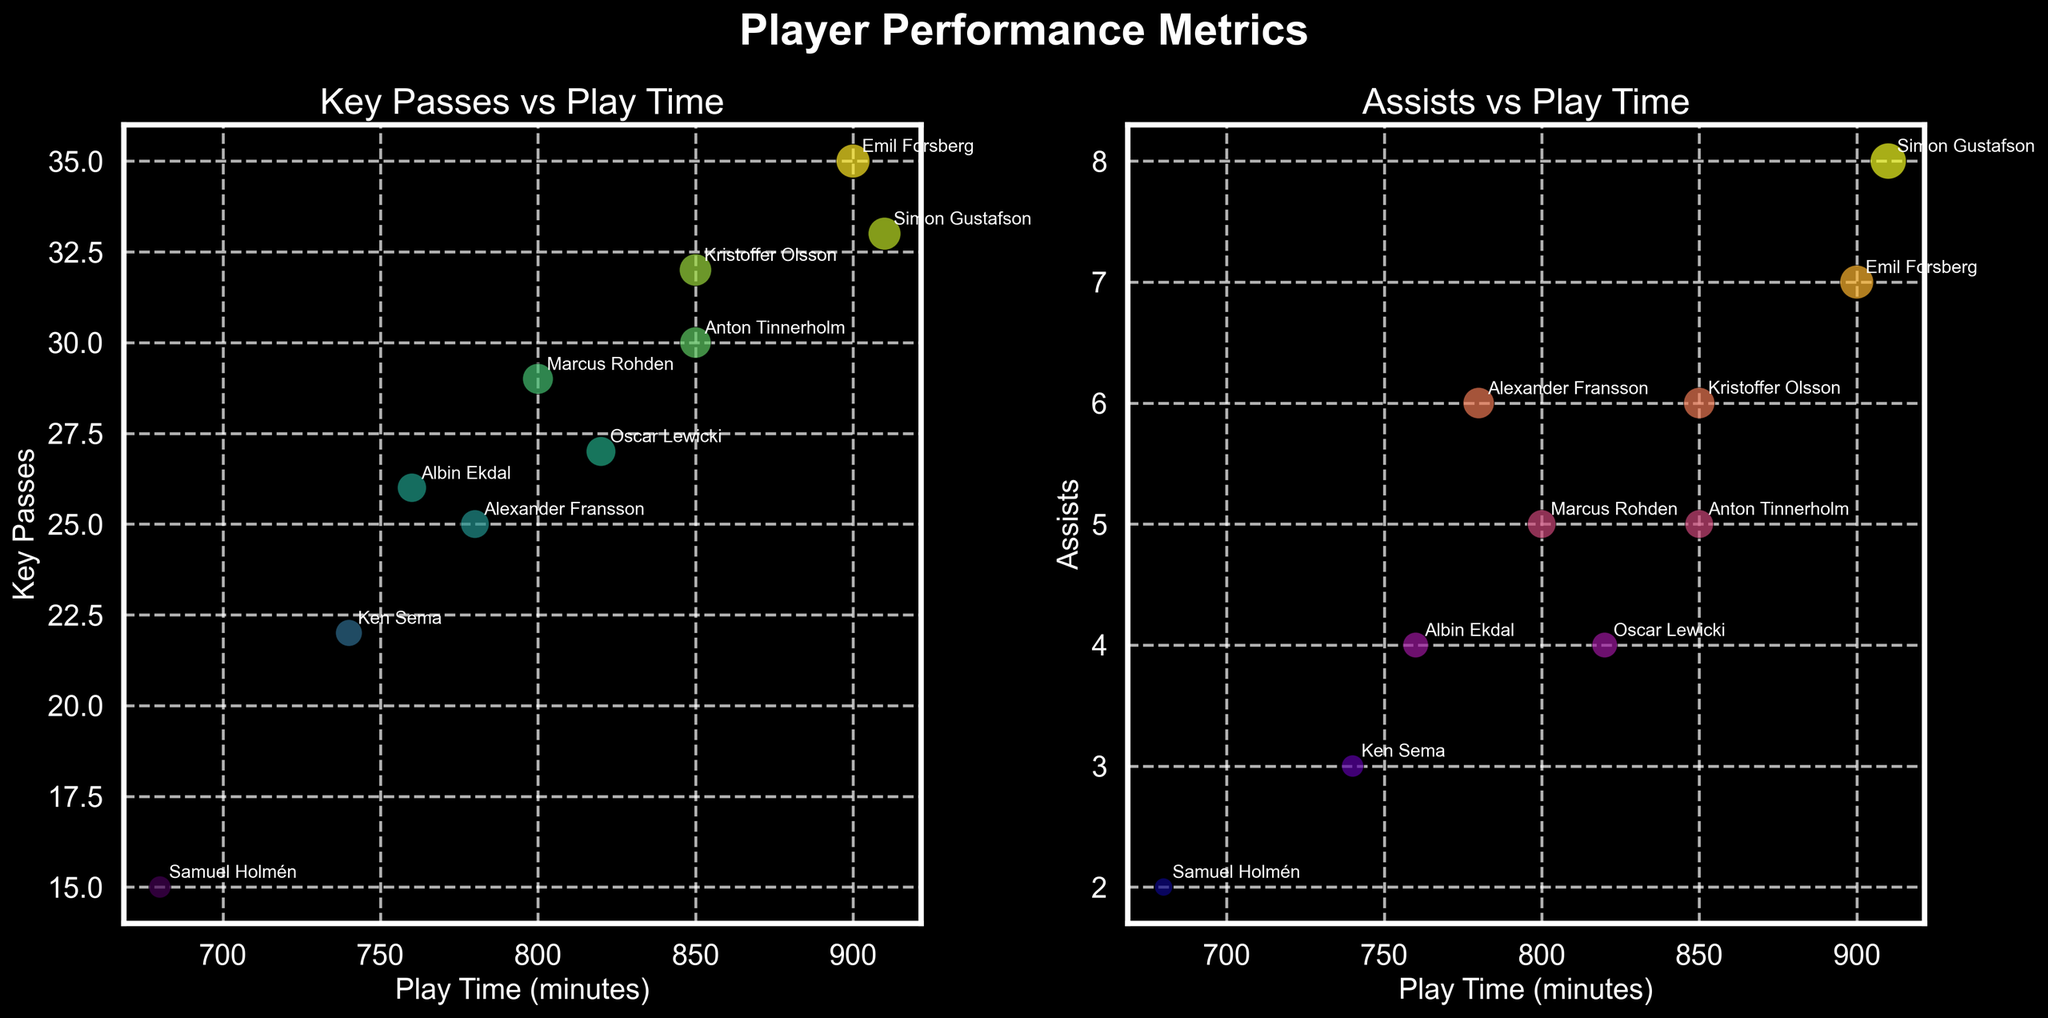How many players have more than 800 minutes of play time? By looking at the x-axis values for play time, select the players with play time greater than 800. These are Emil Forsberg (900), Anton Tinnerholm (850), Simon Gustafson (910), Marcus Rohden (800), and Kristoffer Olsson (850). So, there are 5 players.
Answer: 5 Which player has the highest number of key passes? Check the dot with the highest value on the y-axis of the first subplot (Key Passes vs Play Time). Simon Gustafson tops the chart with 33 key passes.
Answer: Simon Gustafson Who has the most assists, and how many? Look at the second subplot (Assists vs Play Time), find the dot with the highest value on the y-axis. It's Simon Gustafson with 8 assists.
Answer: Simon Gustafson, 8 What is the relationship between play time and key passes? Analyze the first subplot. Generally, higher play time appears to correlate with more key passes, indicated by dots moving upwards as they shift to the right.
Answer: Positive correlation Which player has approximately equal key passes and assists? By comparing both subplots, Emil Forsberg, with 35 key passes and 7 assists, has relatively close numbers without large disparity.
Answer: Emil Forsberg Summarize the number of key passes by players with more than 800 minutes of play time. Identifying players with more than 800 minutes (Emil Forsberg, Anton Tinnerholm, Simon Gustafson, Marcus Rohden, and Kristoffer Olsson) and summing their key passes gives: 35 + 30 + 33 + 29 + 32 = 159 key passes.
Answer: 159 Which player has the least play time? By looking at the second subplot for the smallest x-axis value, Samuel Holmén has the least play time with 680 minutes.
Answer: Samuel Holmén Compare the assists of Alexander Fransson and Oscar Lewicki. Find their points in the assists subplot (Fransson: 6 assists, Lewicki: 4 assists). Fransson has more assists.
Answer: Alexander Fransson Are there any players with exactly five assists? Checking the y-axis values of the second subplot (Assists vs Play Time) for any that hit 5, Anton Tinnerholm and Marcus Rohden both have exactly 5 assists.
Answer: Yes, two players Is there a player who stands out in both key passes and assists? Observing both subplots, Simon Gustafson stands out by being among the top in both key passes (33) and assists (8).
Answer: Simon Gustafson 